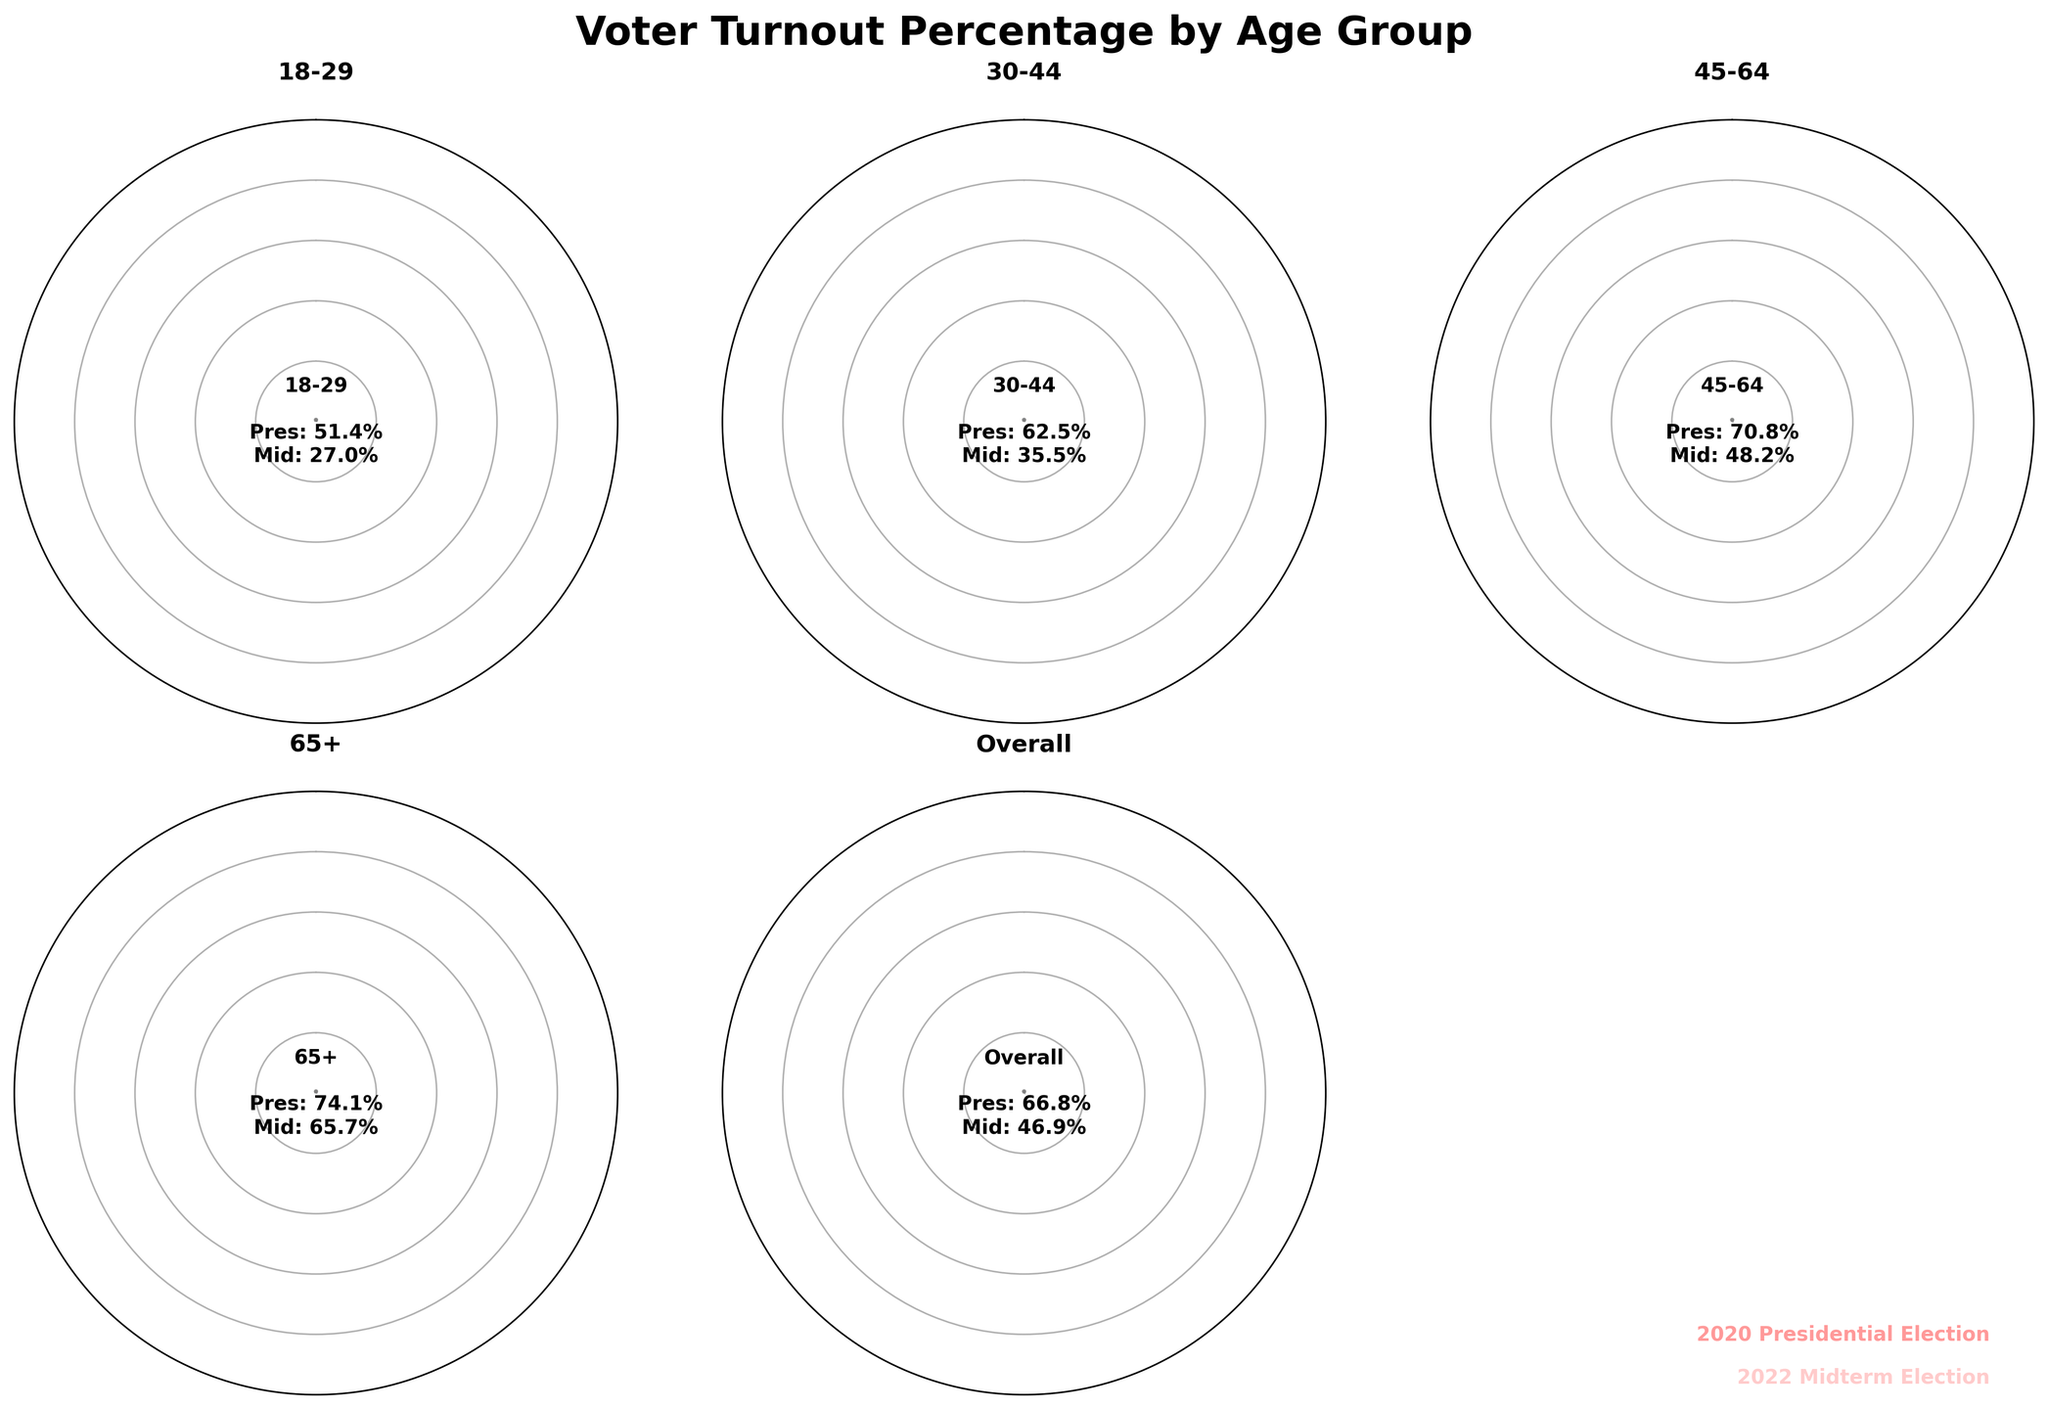what is the voter turnout percentage for the 18-29 age group in the 2020 Presidential Election? The figure shows the turnout percentage for each age group. For the 18-29 age group in the 2020 Presidential Election, it's 51.4%.
Answer: 51.4% what is the difference in voter turnout percentage between the 2020 Presidential Election and the 2022 Midterm Election for the 45-64 age group? The figure shows the voter turnout percentages for each election. For the 45-64 age group, the turnout is 70.8% in the 2020 Presidential Election and 48.2% in the 2022 Midterm Election. The difference is 70.8% - 48.2% = 22.6%.
Answer: 22.6% which age group has the highest voter turnout percentage in the 2022 Midterm Election? By comparing the voter turnout percentages for the 2022 Midterm Election across all age groups in the figure, the 65+ age group has the highest turnout at 65.7%.
Answer: 65+ is the voter turnout percentage for all age groups combined higher in the 2020 Presidential Election or the 2022 Midterm Election? The figure shows the overall voter turnout percentages for both elections. The overall turnout is 66.8% for the 2020 Presidential Election and 46.9% for the 2022 Midterm Election, making it higher in the 2020 Presidential Election.
Answer: 2020 Presidential Election how much lower is the voter turnout percentage for the 30-44 age group in the 2022 Midterm Election compared to the 2020 Presidential Election? The figure shows that the turnout for the 30-44 age group is 62.5% in the 2020 Presidential Election and 35.5% in the 2022 Midterm Election. The difference is 62.5% - 35.5% = 27%.
Answer: 27% what is the average voter turnout percentage for the 18-29 and 65+ age groups in the 2020 Presidential Election? The figure shows that the turnout for the 18-29 age group is 51.4% and for the 65+ age group is 74.1%. The average is (51.4% + 74.1%) / 2 = 62.75%.
Answer: 62.75% what visual element indicates the voter turnout percentage for the 2020 Presidential Election in this gauge chart? The gauge chart uses a colored wedge to show voter turnout percentages. The more opaque wedge indicates the turnout for the 2020 Presidential Election.
Answer: opaque wedge comparing the 45-64 and 65+ age groups, which showed a larger drop in voter turnout percentage from the 2020 Presidential Election to the 2022 Midterm Election? The figure shows 70.8% for the 45-64 age group in the 2020 Presidential Election and 48.2% in the 2022 Midterm Election, a drop of 22.6%. For the 65+ age group, it’s 74.1% in 2020 and 65.7% in 2022, a drop of 8.4%. The 45-64 age group has a larger drop.
Answer: 45-64 what is the range of voter turnout percentages for all age groups in the 2022 Midterm Election? The figure shows the voter turnout percentages for the 2022 Midterm Election across age groups. The percentages range from 27.0% (18-29) to 65.7% (65+). So the range is 65.7% - 27.0% = 38.7%.
Answer: 38.7% which election year had the smallest voter turnout percentage for the 18-29 age group? The figure shows a turnout of 51.4% for the 18-29 age group in the 2020 Presidential Election and 27.0% in the 2022 Midterm Election. The 2022 Midterm Election has the smallest percentage.
Answer: 2022 Midterm Election 